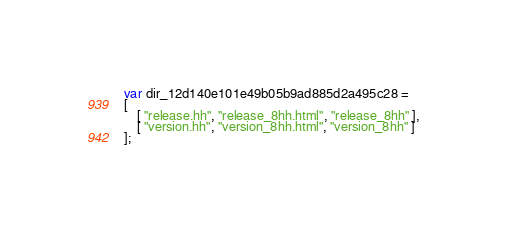<code> <loc_0><loc_0><loc_500><loc_500><_JavaScript_>var dir_12d140e101e49b05b9ad885d2a495c28 =
[
    [ "release.hh", "release_8hh.html", "release_8hh" ],
    [ "version.hh", "version_8hh.html", "version_8hh" ]
];</code> 